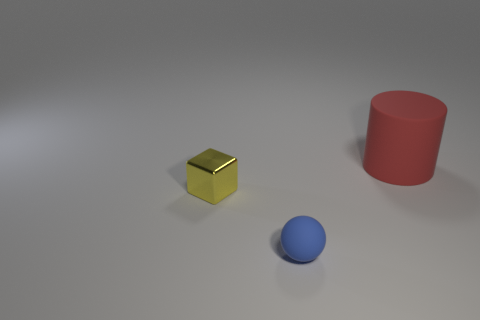Are there any other things that are made of the same material as the small cube?
Provide a succinct answer. No. What is the material of the object on the right side of the small blue object?
Provide a succinct answer. Rubber. What number of objects are matte objects that are to the right of the small blue object or cylinders?
Ensure brevity in your answer.  1. Are there the same number of cylinders that are in front of the blue rubber sphere and small brown cylinders?
Your response must be concise. Yes. Does the blue matte sphere have the same size as the block?
Provide a short and direct response. Yes. What color is the matte ball that is the same size as the metal block?
Your answer should be compact. Blue. Does the red thing have the same size as the rubber thing that is left of the large red rubber object?
Keep it short and to the point. No. What number of matte balls have the same color as the small block?
Your response must be concise. 0. How many things are either tiny balls or rubber objects on the left side of the red matte object?
Provide a succinct answer. 1. Is the size of the rubber thing in front of the small yellow block the same as the matte object behind the shiny block?
Make the answer very short. No. 